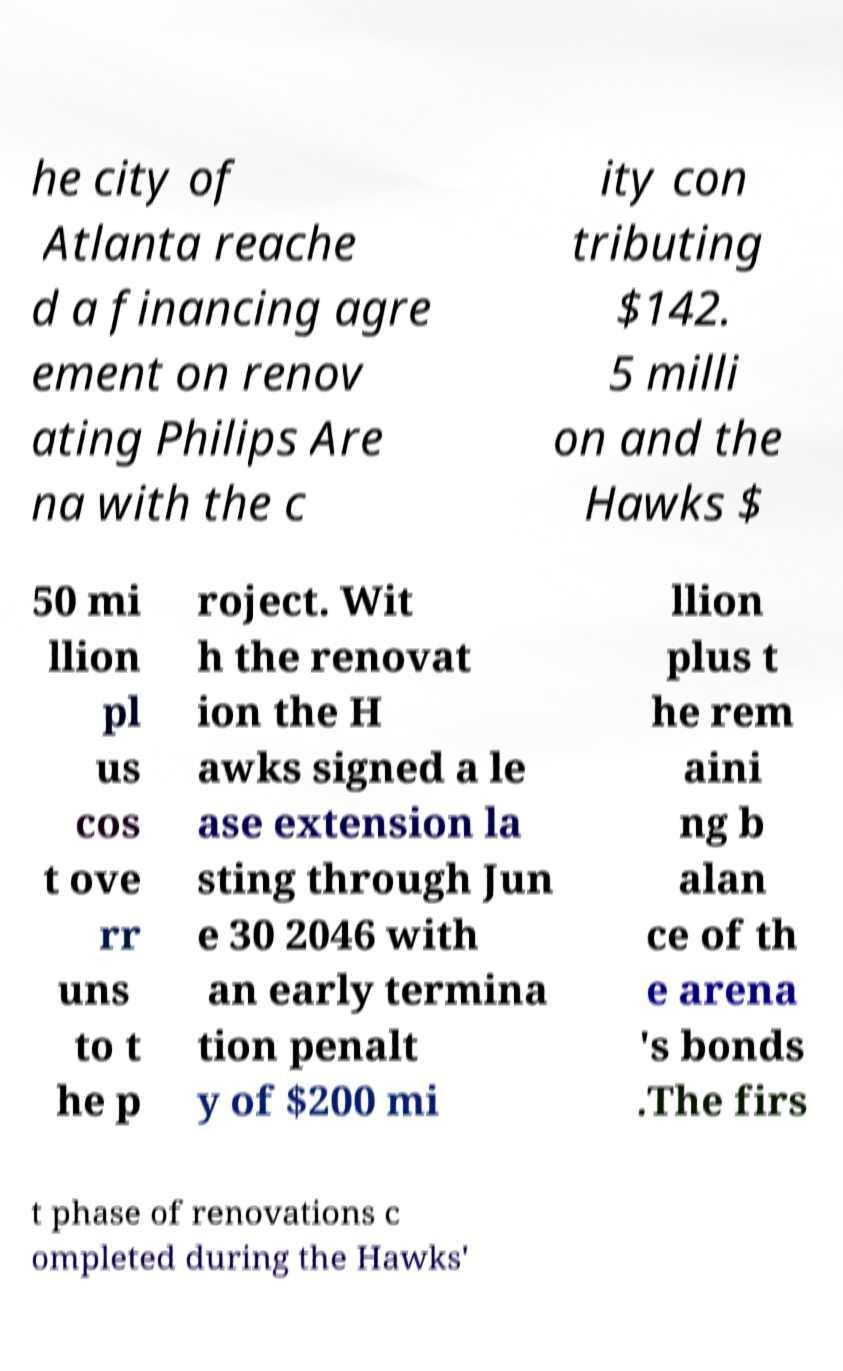Please read and relay the text visible in this image. What does it say? he city of Atlanta reache d a financing agre ement on renov ating Philips Are na with the c ity con tributing $142. 5 milli on and the Hawks $ 50 mi llion pl us cos t ove rr uns to t he p roject. Wit h the renovat ion the H awks signed a le ase extension la sting through Jun e 30 2046 with an early termina tion penalt y of $200 mi llion plus t he rem aini ng b alan ce of th e arena 's bonds .The firs t phase of renovations c ompleted during the Hawks' 